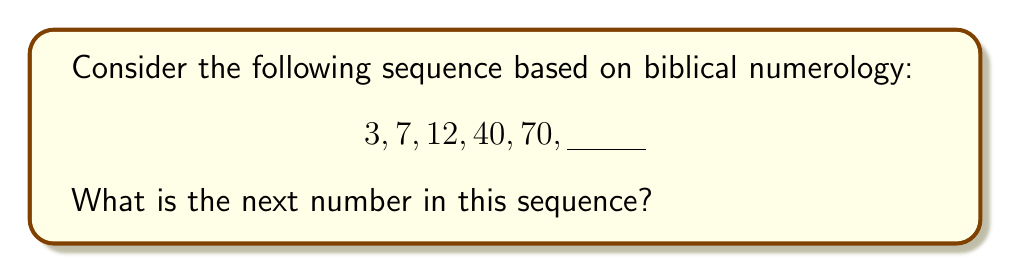Help me with this question. To solve this problem, we need to recognize the biblical significance of each number in the sequence:

1. 3: Represents the Holy Trinity (Father, Son, and Holy Spirit)
2. 7: Symbolizes perfection or completeness in the Bible
3. 12: Represents the 12 tribes of Israel or the 12 apostles
4. 40: Significant in Bible stories (e.g., 40 days of the flood, 40 years in the wilderness)
5. 70: Represents judgment and human delegation (70 elders of Israel)

The next significant biblical number after 70 is 144. This number appears in the Book of Revelation and represents the 144,000 sealed servants of God.

The sequence follows a pattern of increasing biblical significance and symbolism, rather than a mathematical progression. Therefore, based on biblical numerology, the next number in the sequence would be 144.
Answer: 144 